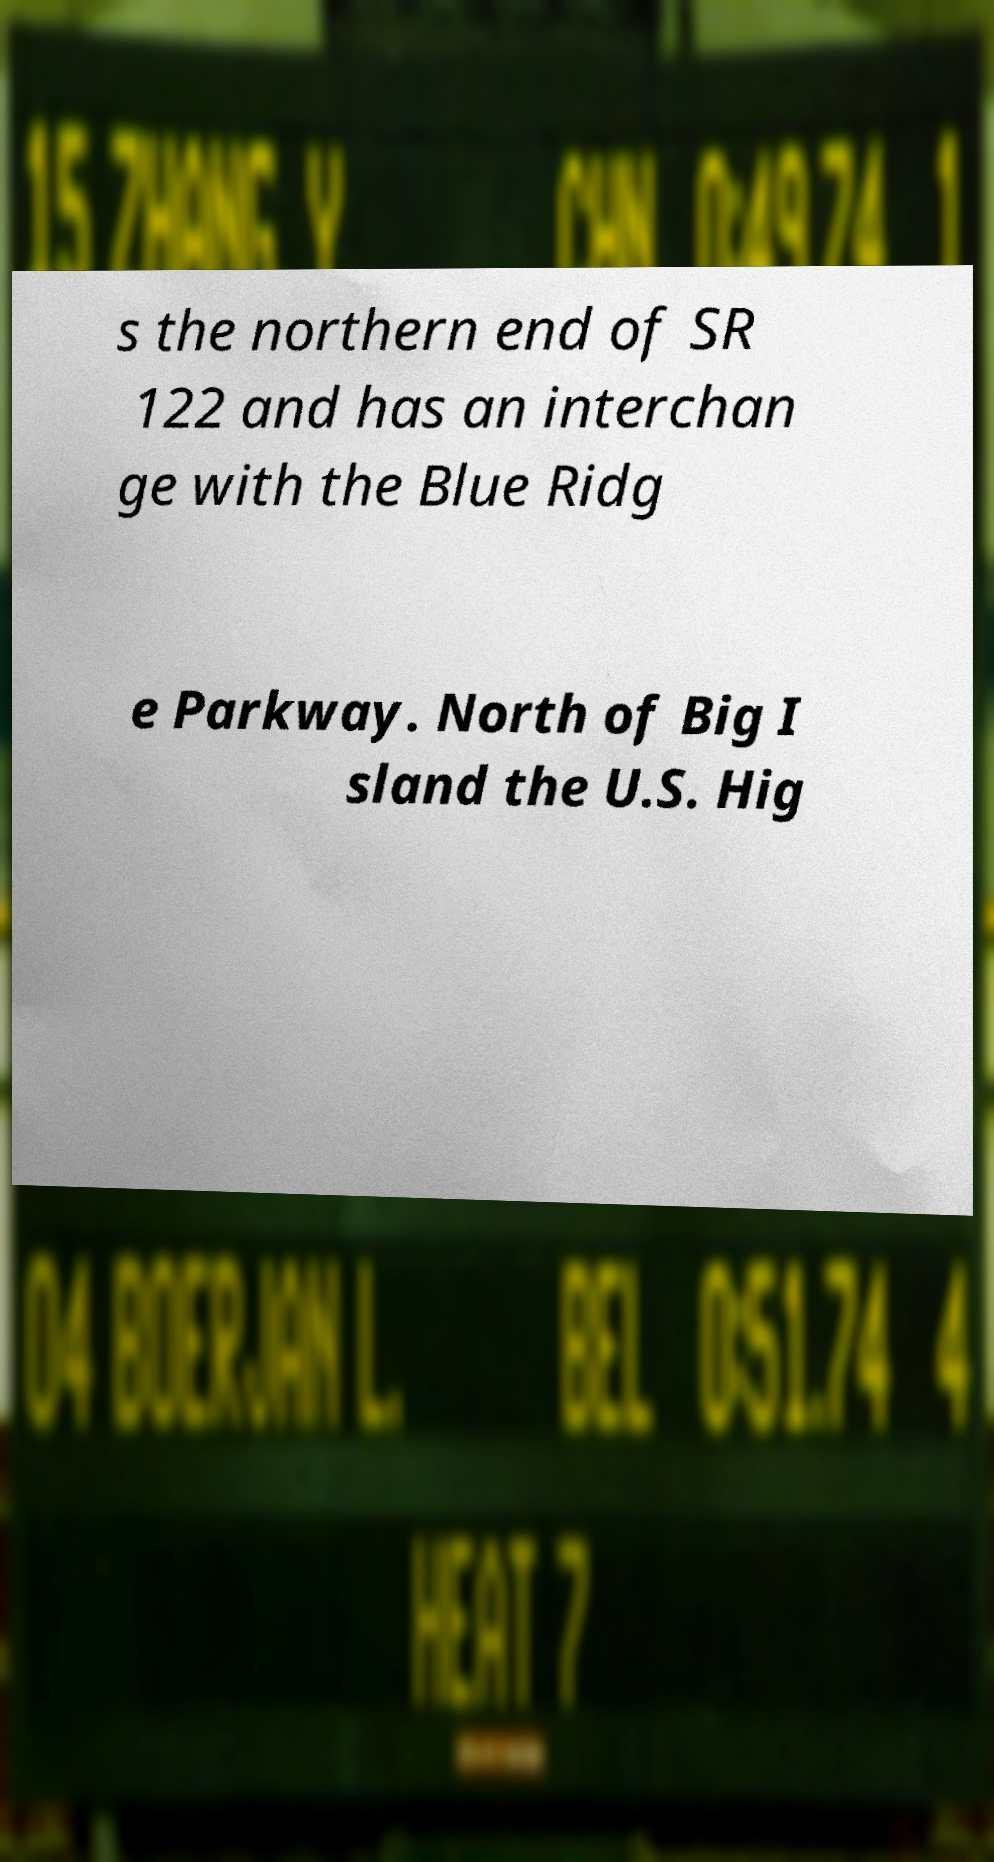Could you extract and type out the text from this image? s the northern end of SR 122 and has an interchan ge with the Blue Ridg e Parkway. North of Big I sland the U.S. Hig 